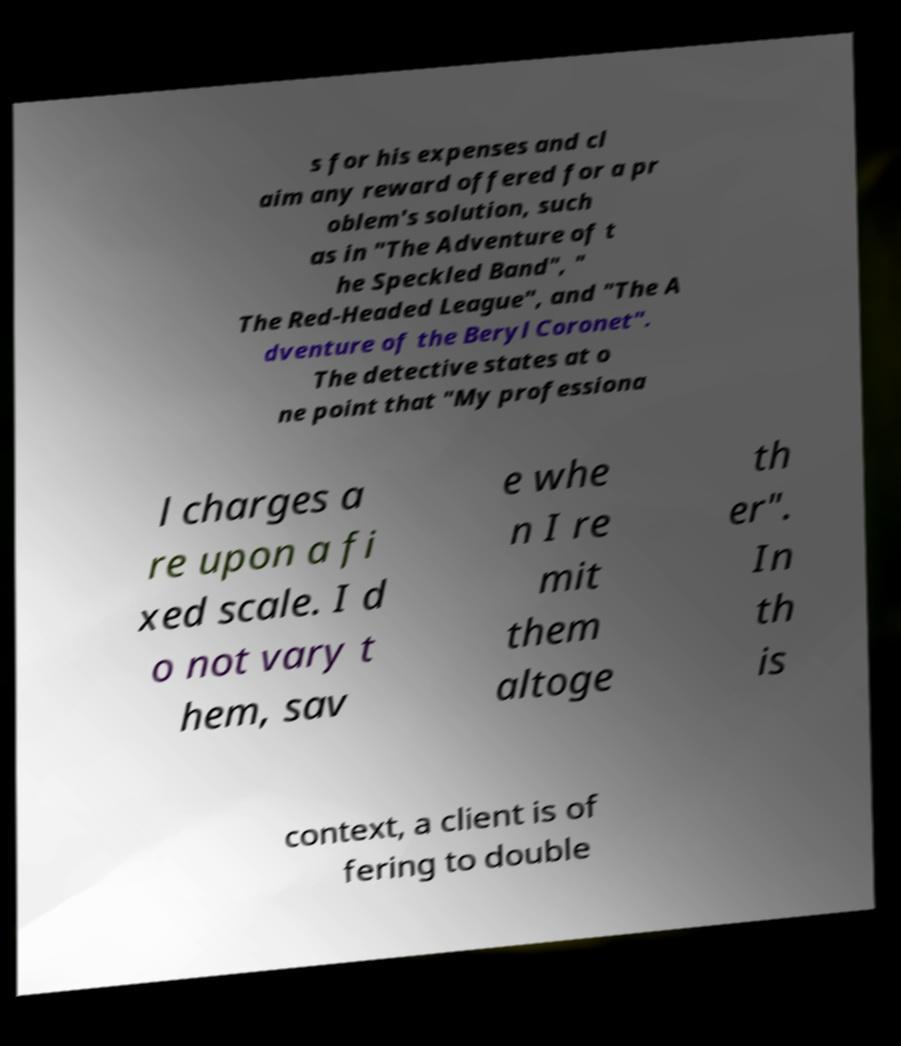Please identify and transcribe the text found in this image. s for his expenses and cl aim any reward offered for a pr oblem's solution, such as in "The Adventure of t he Speckled Band", " The Red-Headed League", and "The A dventure of the Beryl Coronet". The detective states at o ne point that "My professiona l charges a re upon a fi xed scale. I d o not vary t hem, sav e whe n I re mit them altoge th er". In th is context, a client is of fering to double 